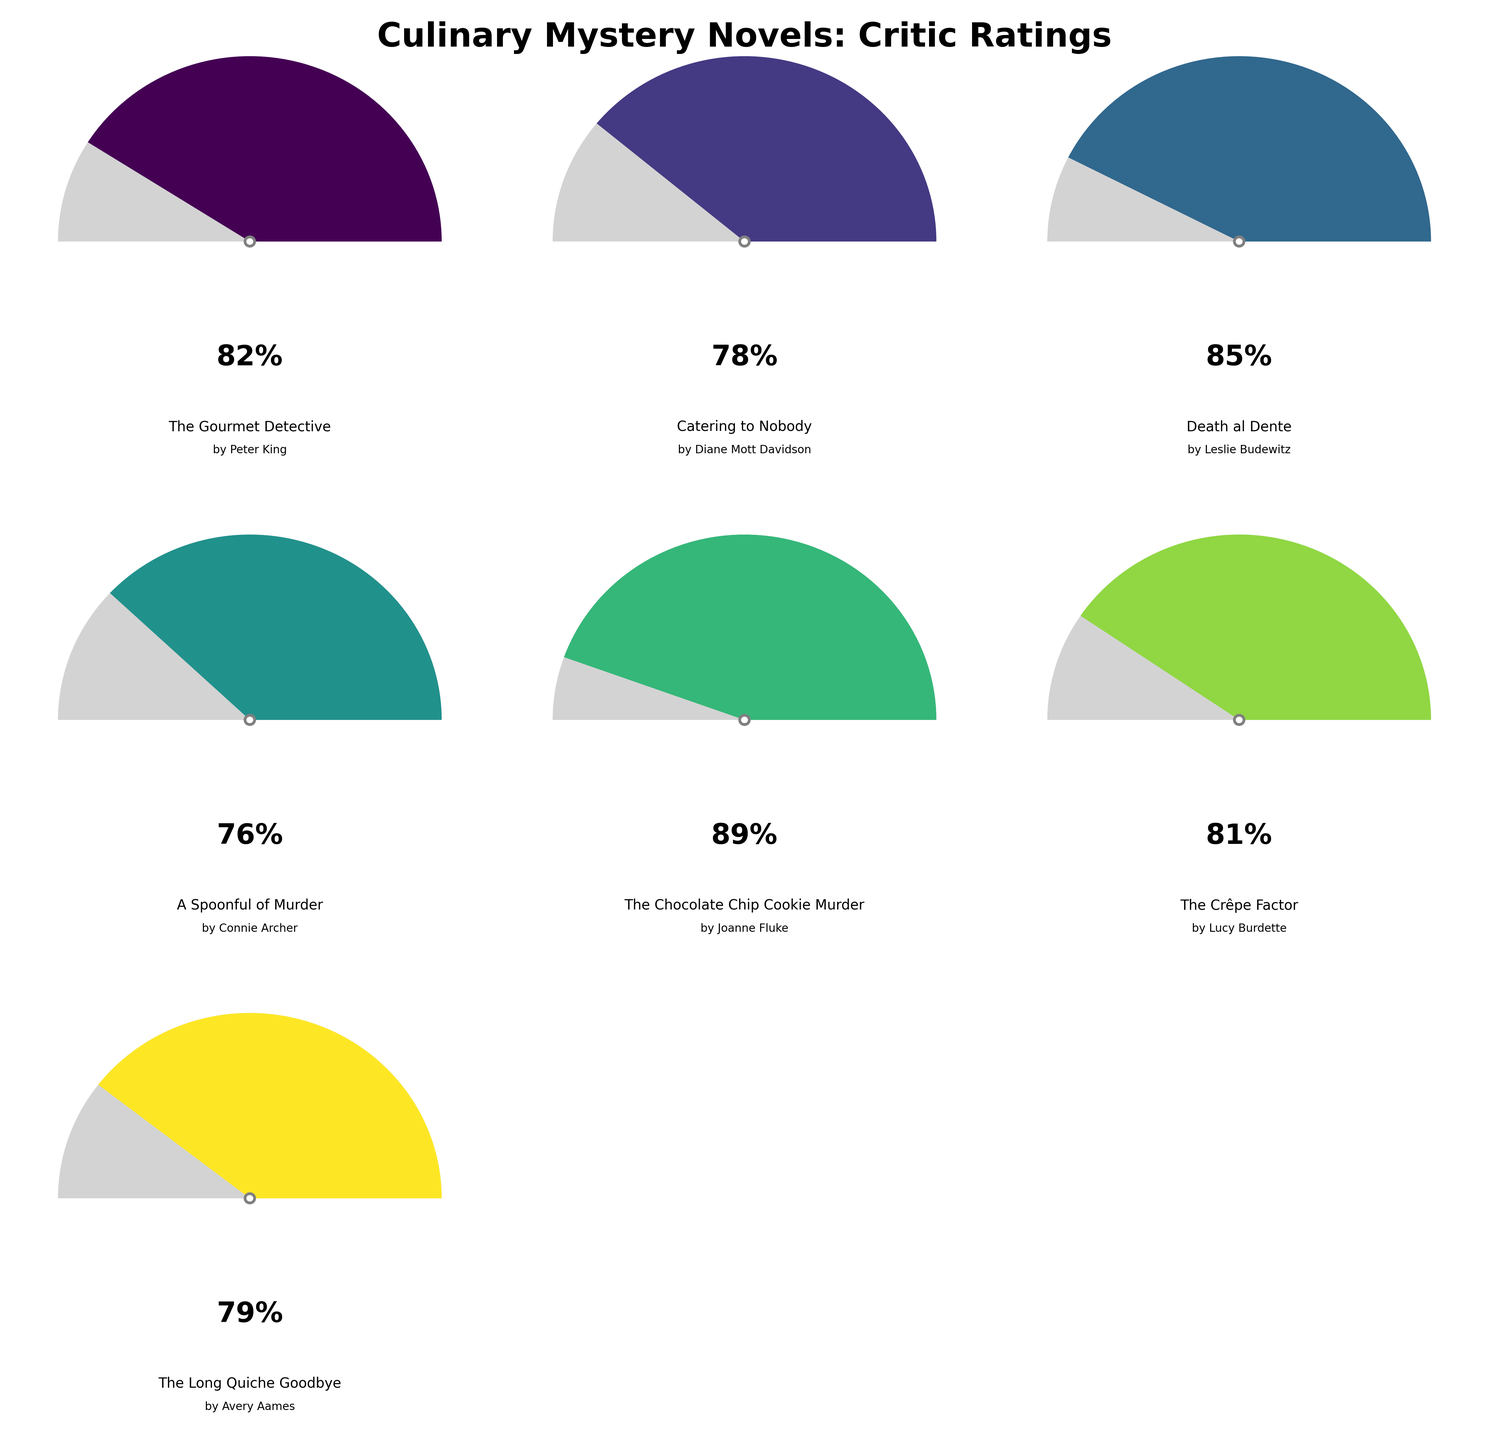what is the overall rating for "The Chocolate Chip Cookie Murder"? Locate the gauge chart for "The Chocolate Chip Cookie Murder" by Joanne Fluke. The gauge's needle points at 89%, indicating the positive review rating.
Answer: 89% Which novel has the lowest rating? Compare all gauge charts. "A Spoonful of Murder" by Connie Archer has the lowest rating at 76%.
Answer: "A Spoonful of Murder" by Connie Archer What is the average rating of all the novels? Sum all the ratings (82 + 78 + 85 + 76 + 89 + 81 + 79 = 570) and then divide by the number of novels (7). The average rating is 570 / 7.
Answer: 81.43% Do more than two novels have above 80% positive reviews? By inspecting each gauge, count the number of novels with ratings above 80%. Four novels ("The Gourmet Detective," "Death al Dente," "The Chocolate Chip Cookie Murder," and "The Crêpe Factor") have ratings over 80%.
Answer: Yes Which novels have ratings below 80%? Identify the gauge charts with ratings under 80%. "Catering to Nobody," "A Spoonful of Murder," and "The Long Quiche Goodbye" all fall into this category.
Answer: "Catering to Nobody," "A Spoonful of Murder," "The Long Quiche Goodbye" Which novel has the highest rating and what is it? Locate the gauge chart with the highest needle angle. "The Chocolate Chip Cookie Murder" by Joanne Fluke has the highest rating at 89%.
Answer: "The Chocolate Chip Cookie Murder" by Joanne Fluke, 89% Is the rating for "Catering to Nobody" higher than "The Long Quiche Goodbye"? Compare the gauge angles for the two novels. "Catering to Nobody" has a 78% rating, which is slightly lower than 79% for "The Long Quiche Goodbye."
Answer: No What's the rating difference between "The Gourmet Detective" and "A Spoonful of Murder"? Subtract the rating of "A Spoonful of Murder" (76%) from "The Gourmet Detective" (82%). The difference is 82 - 76.
Answer: 6% How does the rating for "Death al Dente" compare to the average rating? Calculate the average rating (81.43%). "Death al Dente" has an 85% rating, which is higher than the average.
Answer: Higher 